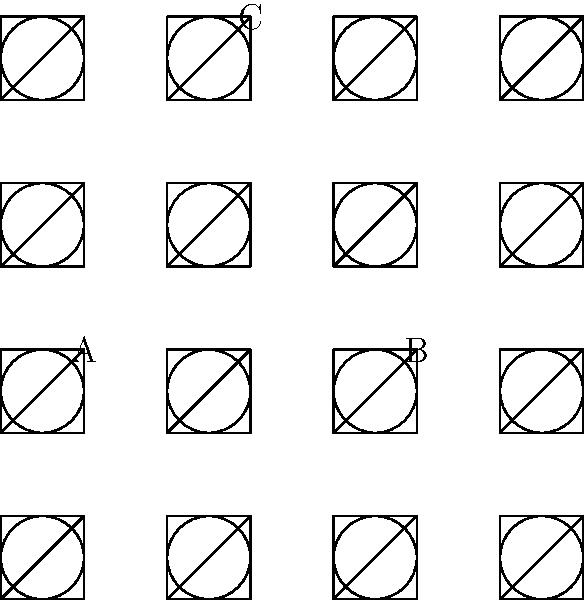Identify the fabric pattern typically associated with 1950s rockabilly fashion from the close-up illustrations provided. To identify the fabric pattern associated with 1950s rockabilly fashion, let's analyze each pattern:

1. Pattern A (bottom left): This shows a checkerboard or gingham pattern, characterized by evenly sized squares. While popular in the 1950s, it's not the most iconic for rockabilly fashion.

2. Pattern B (bottom right): This illustrates a polka dot pattern, consisting of regularly spaced circular dots. Polka dots were extremely popular in 1950s fashion, particularly in rockabilly style.

3. Pattern C (top middle): This depicts a triangular or chevron pattern, which was less common in 1950s rockabilly fashion.

Rockabilly fashion, a subculture style of the 1950s, was heavily influenced by early rock and roll and pinup aesthetics. It often featured bold, playful patterns that embodied the energetic spirit of the era. Among these patterns, polka dots stood out as a quintessential element of rockabilly style.

Polka dots were frequently used in dresses, skirts, and accessories, creating a fun, flirtatious look that perfectly complemented the upbeat rockabilly culture. They were versatile enough to be incorporated into both casual and more dressed-up outfits, making them a staple of the rockabilly wardrobe.

Therefore, the fabric pattern most typically associated with 1950s rockabilly fashion from the given illustrations is the polka dot pattern, labeled as B.
Answer: B (Polka dots) 